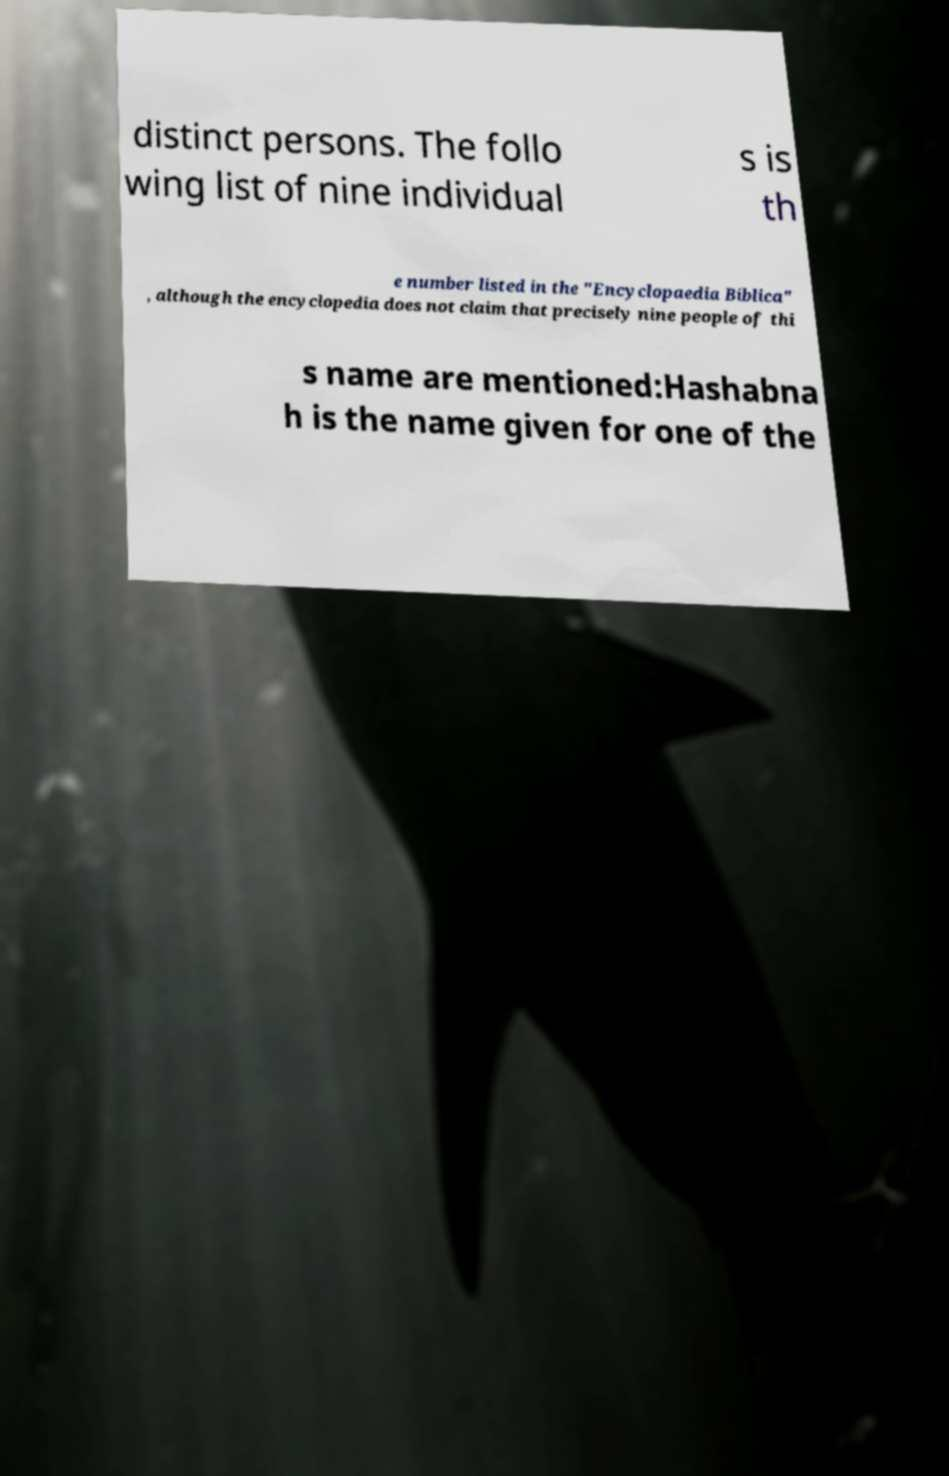Can you read and provide the text displayed in the image?This photo seems to have some interesting text. Can you extract and type it out for me? distinct persons. The follo wing list of nine individual s is th e number listed in the "Encyclopaedia Biblica" , although the encyclopedia does not claim that precisely nine people of thi s name are mentioned:Hashabna h is the name given for one of the 